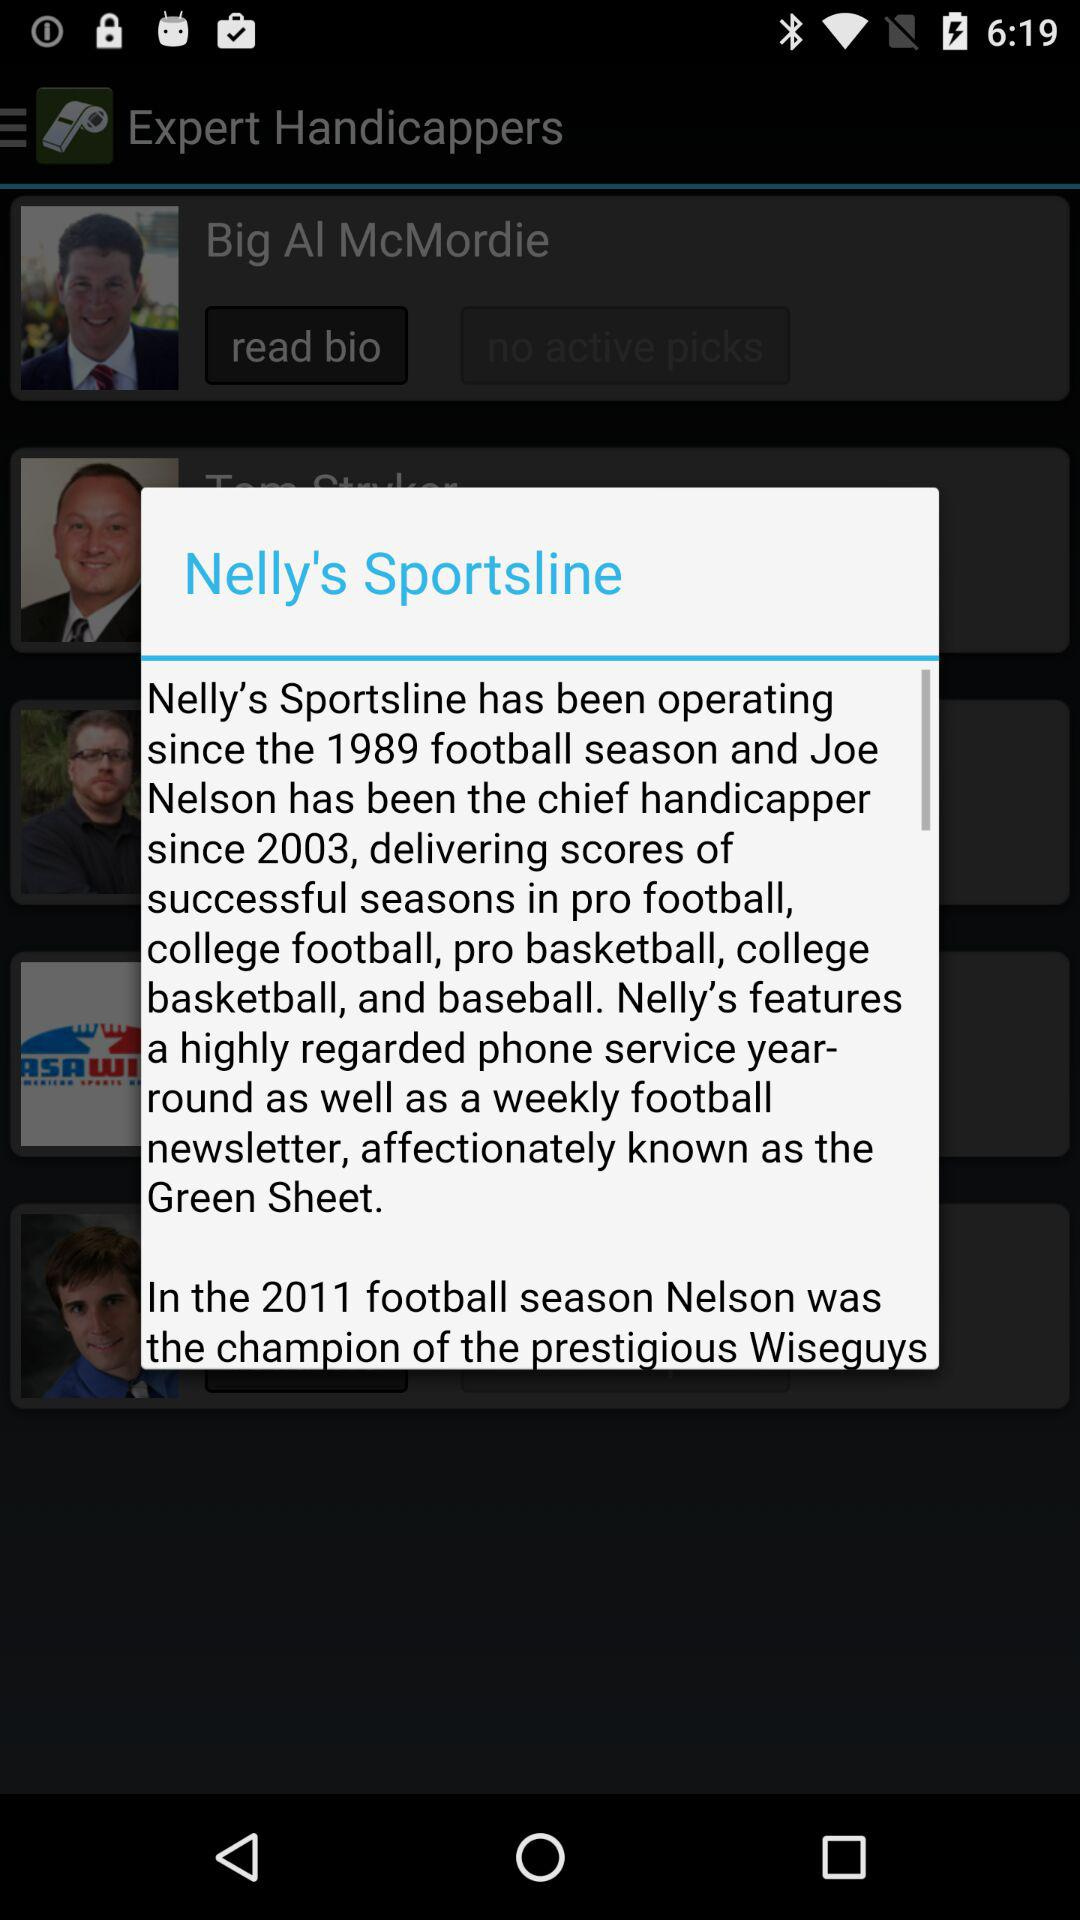Who is the chief handicapper since 2003? The chief handicapper since 2003 is Joe Nelson. 